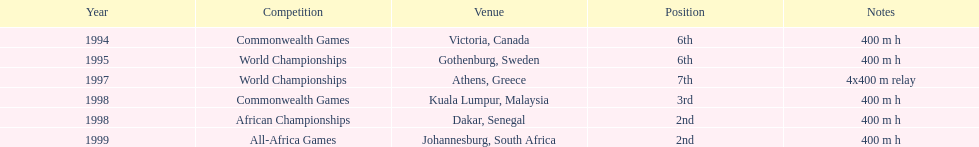In which years did ken harnden achieve a higher position than 5th place? 1998, 1999. 